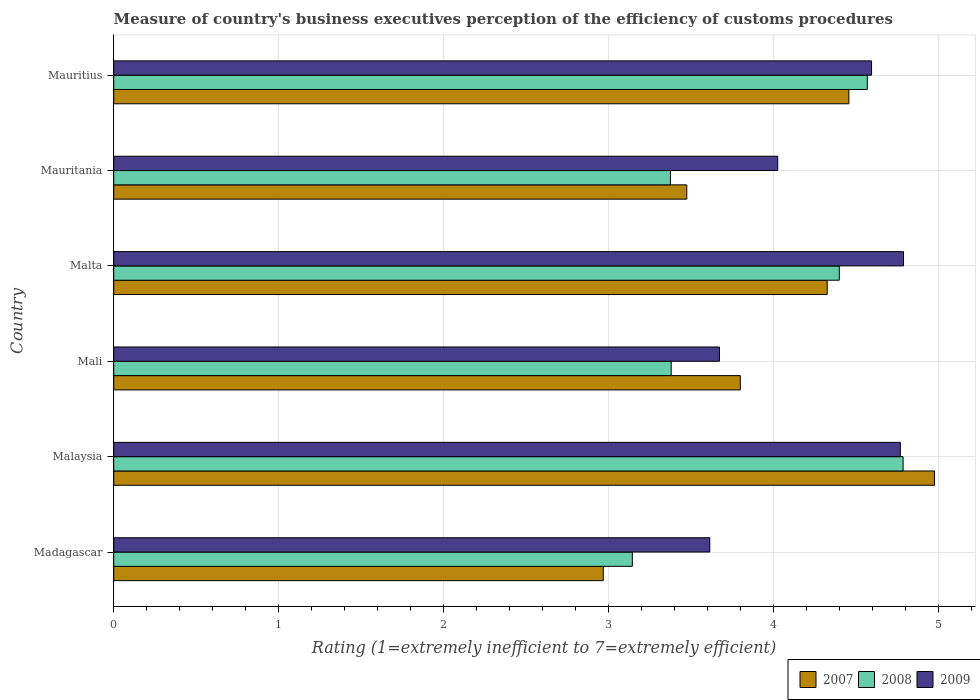How many groups of bars are there?
Make the answer very short. 6. Are the number of bars per tick equal to the number of legend labels?
Your answer should be compact. Yes. Are the number of bars on each tick of the Y-axis equal?
Offer a very short reply. Yes. How many bars are there on the 4th tick from the bottom?
Keep it short and to the point. 3. What is the label of the 1st group of bars from the top?
Provide a succinct answer. Mauritius. What is the rating of the efficiency of customs procedure in 2009 in Mauritius?
Provide a succinct answer. 4.59. Across all countries, what is the maximum rating of the efficiency of customs procedure in 2008?
Your answer should be compact. 4.78. Across all countries, what is the minimum rating of the efficiency of customs procedure in 2007?
Your answer should be very brief. 2.97. In which country was the rating of the efficiency of customs procedure in 2009 maximum?
Ensure brevity in your answer.  Malta. In which country was the rating of the efficiency of customs procedure in 2008 minimum?
Keep it short and to the point. Madagascar. What is the total rating of the efficiency of customs procedure in 2009 in the graph?
Provide a short and direct response. 25.45. What is the difference between the rating of the efficiency of customs procedure in 2008 in Malta and that in Mauritius?
Make the answer very short. -0.17. What is the difference between the rating of the efficiency of customs procedure in 2007 in Malaysia and the rating of the efficiency of customs procedure in 2008 in Malta?
Offer a terse response. 0.58. What is the average rating of the efficiency of customs procedure in 2008 per country?
Offer a very short reply. 3.94. What is the difference between the rating of the efficiency of customs procedure in 2009 and rating of the efficiency of customs procedure in 2008 in Mauritania?
Offer a very short reply. 0.65. In how many countries, is the rating of the efficiency of customs procedure in 2008 greater than 3 ?
Your answer should be compact. 6. What is the ratio of the rating of the efficiency of customs procedure in 2007 in Malta to that in Mauritius?
Offer a terse response. 0.97. Is the difference between the rating of the efficiency of customs procedure in 2009 in Mauritania and Mauritius greater than the difference between the rating of the efficiency of customs procedure in 2008 in Mauritania and Mauritius?
Provide a succinct answer. Yes. What is the difference between the highest and the second highest rating of the efficiency of customs procedure in 2009?
Your answer should be very brief. 0.02. What is the difference between the highest and the lowest rating of the efficiency of customs procedure in 2008?
Ensure brevity in your answer.  1.64. In how many countries, is the rating of the efficiency of customs procedure in 2009 greater than the average rating of the efficiency of customs procedure in 2009 taken over all countries?
Keep it short and to the point. 3. Is the sum of the rating of the efficiency of customs procedure in 2009 in Mali and Mauritania greater than the maximum rating of the efficiency of customs procedure in 2008 across all countries?
Make the answer very short. Yes. What does the 3rd bar from the bottom in Mauritania represents?
Keep it short and to the point. 2009. How many countries are there in the graph?
Offer a very short reply. 6. What is the difference between two consecutive major ticks on the X-axis?
Make the answer very short. 1. Where does the legend appear in the graph?
Offer a terse response. Bottom right. How many legend labels are there?
Give a very brief answer. 3. How are the legend labels stacked?
Your answer should be very brief. Horizontal. What is the title of the graph?
Keep it short and to the point. Measure of country's business executives perception of the efficiency of customs procedures. What is the label or title of the X-axis?
Make the answer very short. Rating (1=extremely inefficient to 7=extremely efficient). What is the label or title of the Y-axis?
Offer a terse response. Country. What is the Rating (1=extremely inefficient to 7=extremely efficient) in 2007 in Madagascar?
Keep it short and to the point. 2.97. What is the Rating (1=extremely inefficient to 7=extremely efficient) in 2008 in Madagascar?
Your answer should be very brief. 3.14. What is the Rating (1=extremely inefficient to 7=extremely efficient) in 2009 in Madagascar?
Your response must be concise. 3.61. What is the Rating (1=extremely inefficient to 7=extremely efficient) of 2007 in Malaysia?
Keep it short and to the point. 4.97. What is the Rating (1=extremely inefficient to 7=extremely efficient) in 2008 in Malaysia?
Ensure brevity in your answer.  4.78. What is the Rating (1=extremely inefficient to 7=extremely efficient) of 2009 in Malaysia?
Provide a short and direct response. 4.77. What is the Rating (1=extremely inefficient to 7=extremely efficient) of 2007 in Mali?
Provide a succinct answer. 3.8. What is the Rating (1=extremely inefficient to 7=extremely efficient) in 2008 in Mali?
Provide a short and direct response. 3.38. What is the Rating (1=extremely inefficient to 7=extremely efficient) in 2009 in Mali?
Ensure brevity in your answer.  3.67. What is the Rating (1=extremely inefficient to 7=extremely efficient) in 2007 in Malta?
Your response must be concise. 4.32. What is the Rating (1=extremely inefficient to 7=extremely efficient) in 2008 in Malta?
Your answer should be very brief. 4.4. What is the Rating (1=extremely inefficient to 7=extremely efficient) of 2009 in Malta?
Your response must be concise. 4.79. What is the Rating (1=extremely inefficient to 7=extremely efficient) of 2007 in Mauritania?
Provide a succinct answer. 3.47. What is the Rating (1=extremely inefficient to 7=extremely efficient) of 2008 in Mauritania?
Your answer should be very brief. 3.37. What is the Rating (1=extremely inefficient to 7=extremely efficient) in 2009 in Mauritania?
Give a very brief answer. 4.02. What is the Rating (1=extremely inefficient to 7=extremely efficient) of 2007 in Mauritius?
Provide a short and direct response. 4.45. What is the Rating (1=extremely inefficient to 7=extremely efficient) of 2008 in Mauritius?
Make the answer very short. 4.57. What is the Rating (1=extremely inefficient to 7=extremely efficient) of 2009 in Mauritius?
Provide a short and direct response. 4.59. Across all countries, what is the maximum Rating (1=extremely inefficient to 7=extremely efficient) in 2007?
Offer a very short reply. 4.97. Across all countries, what is the maximum Rating (1=extremely inefficient to 7=extremely efficient) in 2008?
Offer a terse response. 4.78. Across all countries, what is the maximum Rating (1=extremely inefficient to 7=extremely efficient) of 2009?
Your answer should be very brief. 4.79. Across all countries, what is the minimum Rating (1=extremely inefficient to 7=extremely efficient) of 2007?
Provide a succinct answer. 2.97. Across all countries, what is the minimum Rating (1=extremely inefficient to 7=extremely efficient) in 2008?
Your answer should be compact. 3.14. Across all countries, what is the minimum Rating (1=extremely inefficient to 7=extremely efficient) in 2009?
Your answer should be compact. 3.61. What is the total Rating (1=extremely inefficient to 7=extremely efficient) of 2007 in the graph?
Provide a short and direct response. 23.99. What is the total Rating (1=extremely inefficient to 7=extremely efficient) of 2008 in the graph?
Your answer should be compact. 23.64. What is the total Rating (1=extremely inefficient to 7=extremely efficient) of 2009 in the graph?
Your answer should be compact. 25.45. What is the difference between the Rating (1=extremely inefficient to 7=extremely efficient) of 2007 in Madagascar and that in Malaysia?
Ensure brevity in your answer.  -2.01. What is the difference between the Rating (1=extremely inefficient to 7=extremely efficient) in 2008 in Madagascar and that in Malaysia?
Offer a very short reply. -1.64. What is the difference between the Rating (1=extremely inefficient to 7=extremely efficient) in 2009 in Madagascar and that in Malaysia?
Keep it short and to the point. -1.15. What is the difference between the Rating (1=extremely inefficient to 7=extremely efficient) of 2007 in Madagascar and that in Mali?
Keep it short and to the point. -0.83. What is the difference between the Rating (1=extremely inefficient to 7=extremely efficient) of 2008 in Madagascar and that in Mali?
Offer a very short reply. -0.24. What is the difference between the Rating (1=extremely inefficient to 7=extremely efficient) in 2009 in Madagascar and that in Mali?
Offer a very short reply. -0.06. What is the difference between the Rating (1=extremely inefficient to 7=extremely efficient) of 2007 in Madagascar and that in Malta?
Give a very brief answer. -1.36. What is the difference between the Rating (1=extremely inefficient to 7=extremely efficient) of 2008 in Madagascar and that in Malta?
Ensure brevity in your answer.  -1.25. What is the difference between the Rating (1=extremely inefficient to 7=extremely efficient) in 2009 in Madagascar and that in Malta?
Give a very brief answer. -1.17. What is the difference between the Rating (1=extremely inefficient to 7=extremely efficient) in 2007 in Madagascar and that in Mauritania?
Make the answer very short. -0.51. What is the difference between the Rating (1=extremely inefficient to 7=extremely efficient) in 2008 in Madagascar and that in Mauritania?
Your response must be concise. -0.23. What is the difference between the Rating (1=extremely inefficient to 7=extremely efficient) in 2009 in Madagascar and that in Mauritania?
Keep it short and to the point. -0.41. What is the difference between the Rating (1=extremely inefficient to 7=extremely efficient) in 2007 in Madagascar and that in Mauritius?
Give a very brief answer. -1.49. What is the difference between the Rating (1=extremely inefficient to 7=extremely efficient) in 2008 in Madagascar and that in Mauritius?
Give a very brief answer. -1.42. What is the difference between the Rating (1=extremely inefficient to 7=extremely efficient) in 2009 in Madagascar and that in Mauritius?
Offer a terse response. -0.98. What is the difference between the Rating (1=extremely inefficient to 7=extremely efficient) of 2007 in Malaysia and that in Mali?
Your answer should be compact. 1.18. What is the difference between the Rating (1=extremely inefficient to 7=extremely efficient) in 2008 in Malaysia and that in Mali?
Ensure brevity in your answer.  1.41. What is the difference between the Rating (1=extremely inefficient to 7=extremely efficient) of 2009 in Malaysia and that in Mali?
Give a very brief answer. 1.1. What is the difference between the Rating (1=extremely inefficient to 7=extremely efficient) in 2007 in Malaysia and that in Malta?
Ensure brevity in your answer.  0.65. What is the difference between the Rating (1=extremely inefficient to 7=extremely efficient) in 2008 in Malaysia and that in Malta?
Offer a terse response. 0.39. What is the difference between the Rating (1=extremely inefficient to 7=extremely efficient) of 2009 in Malaysia and that in Malta?
Your response must be concise. -0.02. What is the difference between the Rating (1=extremely inefficient to 7=extremely efficient) of 2007 in Malaysia and that in Mauritania?
Offer a very short reply. 1.5. What is the difference between the Rating (1=extremely inefficient to 7=extremely efficient) of 2008 in Malaysia and that in Mauritania?
Your response must be concise. 1.41. What is the difference between the Rating (1=extremely inefficient to 7=extremely efficient) of 2009 in Malaysia and that in Mauritania?
Ensure brevity in your answer.  0.74. What is the difference between the Rating (1=extremely inefficient to 7=extremely efficient) in 2007 in Malaysia and that in Mauritius?
Offer a terse response. 0.52. What is the difference between the Rating (1=extremely inefficient to 7=extremely efficient) in 2008 in Malaysia and that in Mauritius?
Provide a succinct answer. 0.22. What is the difference between the Rating (1=extremely inefficient to 7=extremely efficient) of 2009 in Malaysia and that in Mauritius?
Your answer should be compact. 0.17. What is the difference between the Rating (1=extremely inefficient to 7=extremely efficient) of 2007 in Mali and that in Malta?
Your answer should be compact. -0.53. What is the difference between the Rating (1=extremely inefficient to 7=extremely efficient) of 2008 in Mali and that in Malta?
Your response must be concise. -1.02. What is the difference between the Rating (1=extremely inefficient to 7=extremely efficient) in 2009 in Mali and that in Malta?
Your answer should be compact. -1.12. What is the difference between the Rating (1=extremely inefficient to 7=extremely efficient) in 2007 in Mali and that in Mauritania?
Provide a short and direct response. 0.32. What is the difference between the Rating (1=extremely inefficient to 7=extremely efficient) in 2008 in Mali and that in Mauritania?
Your answer should be compact. 0. What is the difference between the Rating (1=extremely inefficient to 7=extremely efficient) in 2009 in Mali and that in Mauritania?
Provide a succinct answer. -0.35. What is the difference between the Rating (1=extremely inefficient to 7=extremely efficient) of 2007 in Mali and that in Mauritius?
Your answer should be very brief. -0.66. What is the difference between the Rating (1=extremely inefficient to 7=extremely efficient) in 2008 in Mali and that in Mauritius?
Ensure brevity in your answer.  -1.19. What is the difference between the Rating (1=extremely inefficient to 7=extremely efficient) of 2009 in Mali and that in Mauritius?
Keep it short and to the point. -0.92. What is the difference between the Rating (1=extremely inefficient to 7=extremely efficient) of 2007 in Malta and that in Mauritania?
Offer a very short reply. 0.85. What is the difference between the Rating (1=extremely inefficient to 7=extremely efficient) in 2008 in Malta and that in Mauritania?
Your response must be concise. 1.02. What is the difference between the Rating (1=extremely inefficient to 7=extremely efficient) in 2009 in Malta and that in Mauritania?
Provide a succinct answer. 0.76. What is the difference between the Rating (1=extremely inefficient to 7=extremely efficient) of 2007 in Malta and that in Mauritius?
Provide a short and direct response. -0.13. What is the difference between the Rating (1=extremely inefficient to 7=extremely efficient) in 2008 in Malta and that in Mauritius?
Offer a very short reply. -0.17. What is the difference between the Rating (1=extremely inefficient to 7=extremely efficient) of 2009 in Malta and that in Mauritius?
Ensure brevity in your answer.  0.19. What is the difference between the Rating (1=extremely inefficient to 7=extremely efficient) in 2007 in Mauritania and that in Mauritius?
Your answer should be compact. -0.98. What is the difference between the Rating (1=extremely inefficient to 7=extremely efficient) of 2008 in Mauritania and that in Mauritius?
Your answer should be compact. -1.19. What is the difference between the Rating (1=extremely inefficient to 7=extremely efficient) in 2009 in Mauritania and that in Mauritius?
Give a very brief answer. -0.57. What is the difference between the Rating (1=extremely inefficient to 7=extremely efficient) in 2007 in Madagascar and the Rating (1=extremely inefficient to 7=extremely efficient) in 2008 in Malaysia?
Provide a short and direct response. -1.82. What is the difference between the Rating (1=extremely inefficient to 7=extremely efficient) of 2007 in Madagascar and the Rating (1=extremely inefficient to 7=extremely efficient) of 2009 in Malaysia?
Your answer should be very brief. -1.8. What is the difference between the Rating (1=extremely inefficient to 7=extremely efficient) of 2008 in Madagascar and the Rating (1=extremely inefficient to 7=extremely efficient) of 2009 in Malaysia?
Give a very brief answer. -1.62. What is the difference between the Rating (1=extremely inefficient to 7=extremely efficient) of 2007 in Madagascar and the Rating (1=extremely inefficient to 7=extremely efficient) of 2008 in Mali?
Offer a terse response. -0.41. What is the difference between the Rating (1=extremely inefficient to 7=extremely efficient) of 2007 in Madagascar and the Rating (1=extremely inefficient to 7=extremely efficient) of 2009 in Mali?
Keep it short and to the point. -0.7. What is the difference between the Rating (1=extremely inefficient to 7=extremely efficient) in 2008 in Madagascar and the Rating (1=extremely inefficient to 7=extremely efficient) in 2009 in Mali?
Your response must be concise. -0.53. What is the difference between the Rating (1=extremely inefficient to 7=extremely efficient) of 2007 in Madagascar and the Rating (1=extremely inefficient to 7=extremely efficient) of 2008 in Malta?
Ensure brevity in your answer.  -1.43. What is the difference between the Rating (1=extremely inefficient to 7=extremely efficient) in 2007 in Madagascar and the Rating (1=extremely inefficient to 7=extremely efficient) in 2009 in Malta?
Your answer should be compact. -1.82. What is the difference between the Rating (1=extremely inefficient to 7=extremely efficient) of 2008 in Madagascar and the Rating (1=extremely inefficient to 7=extremely efficient) of 2009 in Malta?
Keep it short and to the point. -1.64. What is the difference between the Rating (1=extremely inefficient to 7=extremely efficient) in 2007 in Madagascar and the Rating (1=extremely inefficient to 7=extremely efficient) in 2008 in Mauritania?
Your answer should be compact. -0.41. What is the difference between the Rating (1=extremely inefficient to 7=extremely efficient) of 2007 in Madagascar and the Rating (1=extremely inefficient to 7=extremely efficient) of 2009 in Mauritania?
Offer a very short reply. -1.06. What is the difference between the Rating (1=extremely inefficient to 7=extremely efficient) of 2008 in Madagascar and the Rating (1=extremely inefficient to 7=extremely efficient) of 2009 in Mauritania?
Offer a terse response. -0.88. What is the difference between the Rating (1=extremely inefficient to 7=extremely efficient) of 2007 in Madagascar and the Rating (1=extremely inefficient to 7=extremely efficient) of 2008 in Mauritius?
Ensure brevity in your answer.  -1.6. What is the difference between the Rating (1=extremely inefficient to 7=extremely efficient) of 2007 in Madagascar and the Rating (1=extremely inefficient to 7=extremely efficient) of 2009 in Mauritius?
Offer a very short reply. -1.63. What is the difference between the Rating (1=extremely inefficient to 7=extremely efficient) of 2008 in Madagascar and the Rating (1=extremely inefficient to 7=extremely efficient) of 2009 in Mauritius?
Make the answer very short. -1.45. What is the difference between the Rating (1=extremely inefficient to 7=extremely efficient) of 2007 in Malaysia and the Rating (1=extremely inefficient to 7=extremely efficient) of 2008 in Mali?
Ensure brevity in your answer.  1.6. What is the difference between the Rating (1=extremely inefficient to 7=extremely efficient) of 2007 in Malaysia and the Rating (1=extremely inefficient to 7=extremely efficient) of 2009 in Mali?
Make the answer very short. 1.3. What is the difference between the Rating (1=extremely inefficient to 7=extremely efficient) in 2008 in Malaysia and the Rating (1=extremely inefficient to 7=extremely efficient) in 2009 in Mali?
Keep it short and to the point. 1.11. What is the difference between the Rating (1=extremely inefficient to 7=extremely efficient) in 2007 in Malaysia and the Rating (1=extremely inefficient to 7=extremely efficient) in 2008 in Malta?
Offer a very short reply. 0.58. What is the difference between the Rating (1=extremely inefficient to 7=extremely efficient) in 2007 in Malaysia and the Rating (1=extremely inefficient to 7=extremely efficient) in 2009 in Malta?
Keep it short and to the point. 0.19. What is the difference between the Rating (1=extremely inefficient to 7=extremely efficient) in 2008 in Malaysia and the Rating (1=extremely inefficient to 7=extremely efficient) in 2009 in Malta?
Provide a short and direct response. -0. What is the difference between the Rating (1=extremely inefficient to 7=extremely efficient) of 2007 in Malaysia and the Rating (1=extremely inefficient to 7=extremely efficient) of 2008 in Mauritania?
Ensure brevity in your answer.  1.6. What is the difference between the Rating (1=extremely inefficient to 7=extremely efficient) in 2007 in Malaysia and the Rating (1=extremely inefficient to 7=extremely efficient) in 2009 in Mauritania?
Give a very brief answer. 0.95. What is the difference between the Rating (1=extremely inefficient to 7=extremely efficient) in 2008 in Malaysia and the Rating (1=extremely inefficient to 7=extremely efficient) in 2009 in Mauritania?
Keep it short and to the point. 0.76. What is the difference between the Rating (1=extremely inefficient to 7=extremely efficient) of 2007 in Malaysia and the Rating (1=extremely inefficient to 7=extremely efficient) of 2008 in Mauritius?
Provide a short and direct response. 0.41. What is the difference between the Rating (1=extremely inefficient to 7=extremely efficient) in 2007 in Malaysia and the Rating (1=extremely inefficient to 7=extremely efficient) in 2009 in Mauritius?
Your answer should be very brief. 0.38. What is the difference between the Rating (1=extremely inefficient to 7=extremely efficient) in 2008 in Malaysia and the Rating (1=extremely inefficient to 7=extremely efficient) in 2009 in Mauritius?
Your answer should be very brief. 0.19. What is the difference between the Rating (1=extremely inefficient to 7=extremely efficient) in 2007 in Mali and the Rating (1=extremely inefficient to 7=extremely efficient) in 2008 in Malta?
Provide a succinct answer. -0.6. What is the difference between the Rating (1=extremely inefficient to 7=extremely efficient) of 2007 in Mali and the Rating (1=extremely inefficient to 7=extremely efficient) of 2009 in Malta?
Your answer should be very brief. -0.99. What is the difference between the Rating (1=extremely inefficient to 7=extremely efficient) of 2008 in Mali and the Rating (1=extremely inefficient to 7=extremely efficient) of 2009 in Malta?
Your answer should be very brief. -1.41. What is the difference between the Rating (1=extremely inefficient to 7=extremely efficient) in 2007 in Mali and the Rating (1=extremely inefficient to 7=extremely efficient) in 2008 in Mauritania?
Your answer should be very brief. 0.42. What is the difference between the Rating (1=extremely inefficient to 7=extremely efficient) of 2007 in Mali and the Rating (1=extremely inefficient to 7=extremely efficient) of 2009 in Mauritania?
Your answer should be compact. -0.23. What is the difference between the Rating (1=extremely inefficient to 7=extremely efficient) in 2008 in Mali and the Rating (1=extremely inefficient to 7=extremely efficient) in 2009 in Mauritania?
Ensure brevity in your answer.  -0.65. What is the difference between the Rating (1=extremely inefficient to 7=extremely efficient) in 2007 in Mali and the Rating (1=extremely inefficient to 7=extremely efficient) in 2008 in Mauritius?
Offer a very short reply. -0.77. What is the difference between the Rating (1=extremely inefficient to 7=extremely efficient) of 2007 in Mali and the Rating (1=extremely inefficient to 7=extremely efficient) of 2009 in Mauritius?
Your answer should be very brief. -0.8. What is the difference between the Rating (1=extremely inefficient to 7=extremely efficient) in 2008 in Mali and the Rating (1=extremely inefficient to 7=extremely efficient) in 2009 in Mauritius?
Give a very brief answer. -1.21. What is the difference between the Rating (1=extremely inefficient to 7=extremely efficient) in 2007 in Malta and the Rating (1=extremely inefficient to 7=extremely efficient) in 2008 in Mauritania?
Keep it short and to the point. 0.95. What is the difference between the Rating (1=extremely inefficient to 7=extremely efficient) of 2007 in Malta and the Rating (1=extremely inefficient to 7=extremely efficient) of 2009 in Mauritania?
Offer a very short reply. 0.3. What is the difference between the Rating (1=extremely inefficient to 7=extremely efficient) in 2008 in Malta and the Rating (1=extremely inefficient to 7=extremely efficient) in 2009 in Mauritania?
Provide a succinct answer. 0.37. What is the difference between the Rating (1=extremely inefficient to 7=extremely efficient) of 2007 in Malta and the Rating (1=extremely inefficient to 7=extremely efficient) of 2008 in Mauritius?
Your answer should be compact. -0.24. What is the difference between the Rating (1=extremely inefficient to 7=extremely efficient) in 2007 in Malta and the Rating (1=extremely inefficient to 7=extremely efficient) in 2009 in Mauritius?
Your response must be concise. -0.27. What is the difference between the Rating (1=extremely inefficient to 7=extremely efficient) of 2008 in Malta and the Rating (1=extremely inefficient to 7=extremely efficient) of 2009 in Mauritius?
Your answer should be compact. -0.2. What is the difference between the Rating (1=extremely inefficient to 7=extremely efficient) in 2007 in Mauritania and the Rating (1=extremely inefficient to 7=extremely efficient) in 2008 in Mauritius?
Provide a succinct answer. -1.09. What is the difference between the Rating (1=extremely inefficient to 7=extremely efficient) in 2007 in Mauritania and the Rating (1=extremely inefficient to 7=extremely efficient) in 2009 in Mauritius?
Keep it short and to the point. -1.12. What is the difference between the Rating (1=extremely inefficient to 7=extremely efficient) of 2008 in Mauritania and the Rating (1=extremely inefficient to 7=extremely efficient) of 2009 in Mauritius?
Provide a succinct answer. -1.22. What is the average Rating (1=extremely inefficient to 7=extremely efficient) in 2007 per country?
Provide a succinct answer. 4. What is the average Rating (1=extremely inefficient to 7=extremely efficient) of 2008 per country?
Ensure brevity in your answer.  3.94. What is the average Rating (1=extremely inefficient to 7=extremely efficient) of 2009 per country?
Offer a very short reply. 4.24. What is the difference between the Rating (1=extremely inefficient to 7=extremely efficient) in 2007 and Rating (1=extremely inefficient to 7=extremely efficient) in 2008 in Madagascar?
Offer a very short reply. -0.18. What is the difference between the Rating (1=extremely inefficient to 7=extremely efficient) of 2007 and Rating (1=extremely inefficient to 7=extremely efficient) of 2009 in Madagascar?
Ensure brevity in your answer.  -0.65. What is the difference between the Rating (1=extremely inefficient to 7=extremely efficient) of 2008 and Rating (1=extremely inefficient to 7=extremely efficient) of 2009 in Madagascar?
Keep it short and to the point. -0.47. What is the difference between the Rating (1=extremely inefficient to 7=extremely efficient) in 2007 and Rating (1=extremely inefficient to 7=extremely efficient) in 2008 in Malaysia?
Make the answer very short. 0.19. What is the difference between the Rating (1=extremely inefficient to 7=extremely efficient) in 2007 and Rating (1=extremely inefficient to 7=extremely efficient) in 2009 in Malaysia?
Ensure brevity in your answer.  0.21. What is the difference between the Rating (1=extremely inefficient to 7=extremely efficient) of 2008 and Rating (1=extremely inefficient to 7=extremely efficient) of 2009 in Malaysia?
Give a very brief answer. 0.02. What is the difference between the Rating (1=extremely inefficient to 7=extremely efficient) of 2007 and Rating (1=extremely inefficient to 7=extremely efficient) of 2008 in Mali?
Offer a terse response. 0.42. What is the difference between the Rating (1=extremely inefficient to 7=extremely efficient) of 2007 and Rating (1=extremely inefficient to 7=extremely efficient) of 2009 in Mali?
Provide a succinct answer. 0.13. What is the difference between the Rating (1=extremely inefficient to 7=extremely efficient) in 2008 and Rating (1=extremely inefficient to 7=extremely efficient) in 2009 in Mali?
Make the answer very short. -0.29. What is the difference between the Rating (1=extremely inefficient to 7=extremely efficient) in 2007 and Rating (1=extremely inefficient to 7=extremely efficient) in 2008 in Malta?
Offer a very short reply. -0.07. What is the difference between the Rating (1=extremely inefficient to 7=extremely efficient) in 2007 and Rating (1=extremely inefficient to 7=extremely efficient) in 2009 in Malta?
Your answer should be compact. -0.46. What is the difference between the Rating (1=extremely inefficient to 7=extremely efficient) in 2008 and Rating (1=extremely inefficient to 7=extremely efficient) in 2009 in Malta?
Offer a terse response. -0.39. What is the difference between the Rating (1=extremely inefficient to 7=extremely efficient) of 2007 and Rating (1=extremely inefficient to 7=extremely efficient) of 2008 in Mauritania?
Offer a very short reply. 0.1. What is the difference between the Rating (1=extremely inefficient to 7=extremely efficient) in 2007 and Rating (1=extremely inefficient to 7=extremely efficient) in 2009 in Mauritania?
Your response must be concise. -0.55. What is the difference between the Rating (1=extremely inefficient to 7=extremely efficient) of 2008 and Rating (1=extremely inefficient to 7=extremely efficient) of 2009 in Mauritania?
Give a very brief answer. -0.65. What is the difference between the Rating (1=extremely inefficient to 7=extremely efficient) of 2007 and Rating (1=extremely inefficient to 7=extremely efficient) of 2008 in Mauritius?
Your answer should be very brief. -0.11. What is the difference between the Rating (1=extremely inefficient to 7=extremely efficient) of 2007 and Rating (1=extremely inefficient to 7=extremely efficient) of 2009 in Mauritius?
Offer a terse response. -0.14. What is the difference between the Rating (1=extremely inefficient to 7=extremely efficient) of 2008 and Rating (1=extremely inefficient to 7=extremely efficient) of 2009 in Mauritius?
Your answer should be compact. -0.03. What is the ratio of the Rating (1=extremely inefficient to 7=extremely efficient) in 2007 in Madagascar to that in Malaysia?
Ensure brevity in your answer.  0.6. What is the ratio of the Rating (1=extremely inefficient to 7=extremely efficient) of 2008 in Madagascar to that in Malaysia?
Your answer should be very brief. 0.66. What is the ratio of the Rating (1=extremely inefficient to 7=extremely efficient) in 2009 in Madagascar to that in Malaysia?
Offer a very short reply. 0.76. What is the ratio of the Rating (1=extremely inefficient to 7=extremely efficient) in 2007 in Madagascar to that in Mali?
Ensure brevity in your answer.  0.78. What is the ratio of the Rating (1=extremely inefficient to 7=extremely efficient) in 2008 in Madagascar to that in Mali?
Provide a short and direct response. 0.93. What is the ratio of the Rating (1=extremely inefficient to 7=extremely efficient) in 2009 in Madagascar to that in Mali?
Offer a very short reply. 0.98. What is the ratio of the Rating (1=extremely inefficient to 7=extremely efficient) in 2007 in Madagascar to that in Malta?
Ensure brevity in your answer.  0.69. What is the ratio of the Rating (1=extremely inefficient to 7=extremely efficient) in 2008 in Madagascar to that in Malta?
Ensure brevity in your answer.  0.71. What is the ratio of the Rating (1=extremely inefficient to 7=extremely efficient) in 2009 in Madagascar to that in Malta?
Offer a terse response. 0.75. What is the ratio of the Rating (1=extremely inefficient to 7=extremely efficient) of 2007 in Madagascar to that in Mauritania?
Provide a succinct answer. 0.85. What is the ratio of the Rating (1=extremely inefficient to 7=extremely efficient) of 2008 in Madagascar to that in Mauritania?
Your answer should be very brief. 0.93. What is the ratio of the Rating (1=extremely inefficient to 7=extremely efficient) in 2009 in Madagascar to that in Mauritania?
Make the answer very short. 0.9. What is the ratio of the Rating (1=extremely inefficient to 7=extremely efficient) in 2007 in Madagascar to that in Mauritius?
Your response must be concise. 0.67. What is the ratio of the Rating (1=extremely inefficient to 7=extremely efficient) of 2008 in Madagascar to that in Mauritius?
Provide a succinct answer. 0.69. What is the ratio of the Rating (1=extremely inefficient to 7=extremely efficient) in 2009 in Madagascar to that in Mauritius?
Provide a short and direct response. 0.79. What is the ratio of the Rating (1=extremely inefficient to 7=extremely efficient) in 2007 in Malaysia to that in Mali?
Provide a short and direct response. 1.31. What is the ratio of the Rating (1=extremely inefficient to 7=extremely efficient) of 2008 in Malaysia to that in Mali?
Offer a very short reply. 1.42. What is the ratio of the Rating (1=extremely inefficient to 7=extremely efficient) of 2009 in Malaysia to that in Mali?
Make the answer very short. 1.3. What is the ratio of the Rating (1=extremely inefficient to 7=extremely efficient) in 2007 in Malaysia to that in Malta?
Provide a short and direct response. 1.15. What is the ratio of the Rating (1=extremely inefficient to 7=extremely efficient) of 2008 in Malaysia to that in Malta?
Offer a terse response. 1.09. What is the ratio of the Rating (1=extremely inefficient to 7=extremely efficient) in 2009 in Malaysia to that in Malta?
Make the answer very short. 1. What is the ratio of the Rating (1=extremely inefficient to 7=extremely efficient) in 2007 in Malaysia to that in Mauritania?
Keep it short and to the point. 1.43. What is the ratio of the Rating (1=extremely inefficient to 7=extremely efficient) of 2008 in Malaysia to that in Mauritania?
Provide a short and direct response. 1.42. What is the ratio of the Rating (1=extremely inefficient to 7=extremely efficient) of 2009 in Malaysia to that in Mauritania?
Your response must be concise. 1.18. What is the ratio of the Rating (1=extremely inefficient to 7=extremely efficient) of 2007 in Malaysia to that in Mauritius?
Your response must be concise. 1.12. What is the ratio of the Rating (1=extremely inefficient to 7=extremely efficient) of 2008 in Malaysia to that in Mauritius?
Ensure brevity in your answer.  1.05. What is the ratio of the Rating (1=extremely inefficient to 7=extremely efficient) in 2009 in Malaysia to that in Mauritius?
Offer a terse response. 1.04. What is the ratio of the Rating (1=extremely inefficient to 7=extremely efficient) of 2007 in Mali to that in Malta?
Your answer should be very brief. 0.88. What is the ratio of the Rating (1=extremely inefficient to 7=extremely efficient) of 2008 in Mali to that in Malta?
Ensure brevity in your answer.  0.77. What is the ratio of the Rating (1=extremely inefficient to 7=extremely efficient) of 2009 in Mali to that in Malta?
Provide a short and direct response. 0.77. What is the ratio of the Rating (1=extremely inefficient to 7=extremely efficient) in 2007 in Mali to that in Mauritania?
Keep it short and to the point. 1.09. What is the ratio of the Rating (1=extremely inefficient to 7=extremely efficient) of 2008 in Mali to that in Mauritania?
Ensure brevity in your answer.  1. What is the ratio of the Rating (1=extremely inefficient to 7=extremely efficient) in 2009 in Mali to that in Mauritania?
Provide a succinct answer. 0.91. What is the ratio of the Rating (1=extremely inefficient to 7=extremely efficient) of 2007 in Mali to that in Mauritius?
Keep it short and to the point. 0.85. What is the ratio of the Rating (1=extremely inefficient to 7=extremely efficient) in 2008 in Mali to that in Mauritius?
Ensure brevity in your answer.  0.74. What is the ratio of the Rating (1=extremely inefficient to 7=extremely efficient) in 2009 in Mali to that in Mauritius?
Your answer should be very brief. 0.8. What is the ratio of the Rating (1=extremely inefficient to 7=extremely efficient) of 2007 in Malta to that in Mauritania?
Your answer should be compact. 1.25. What is the ratio of the Rating (1=extremely inefficient to 7=extremely efficient) in 2008 in Malta to that in Mauritania?
Your answer should be compact. 1.3. What is the ratio of the Rating (1=extremely inefficient to 7=extremely efficient) in 2009 in Malta to that in Mauritania?
Offer a very short reply. 1.19. What is the ratio of the Rating (1=extremely inefficient to 7=extremely efficient) of 2007 in Malta to that in Mauritius?
Offer a terse response. 0.97. What is the ratio of the Rating (1=extremely inefficient to 7=extremely efficient) in 2008 in Malta to that in Mauritius?
Provide a short and direct response. 0.96. What is the ratio of the Rating (1=extremely inefficient to 7=extremely efficient) in 2009 in Malta to that in Mauritius?
Ensure brevity in your answer.  1.04. What is the ratio of the Rating (1=extremely inefficient to 7=extremely efficient) of 2007 in Mauritania to that in Mauritius?
Provide a short and direct response. 0.78. What is the ratio of the Rating (1=extremely inefficient to 7=extremely efficient) in 2008 in Mauritania to that in Mauritius?
Give a very brief answer. 0.74. What is the ratio of the Rating (1=extremely inefficient to 7=extremely efficient) in 2009 in Mauritania to that in Mauritius?
Offer a terse response. 0.88. What is the difference between the highest and the second highest Rating (1=extremely inefficient to 7=extremely efficient) of 2007?
Provide a short and direct response. 0.52. What is the difference between the highest and the second highest Rating (1=extremely inefficient to 7=extremely efficient) of 2008?
Offer a very short reply. 0.22. What is the difference between the highest and the second highest Rating (1=extremely inefficient to 7=extremely efficient) of 2009?
Make the answer very short. 0.02. What is the difference between the highest and the lowest Rating (1=extremely inefficient to 7=extremely efficient) of 2007?
Offer a very short reply. 2.01. What is the difference between the highest and the lowest Rating (1=extremely inefficient to 7=extremely efficient) in 2008?
Give a very brief answer. 1.64. What is the difference between the highest and the lowest Rating (1=extremely inefficient to 7=extremely efficient) in 2009?
Keep it short and to the point. 1.17. 